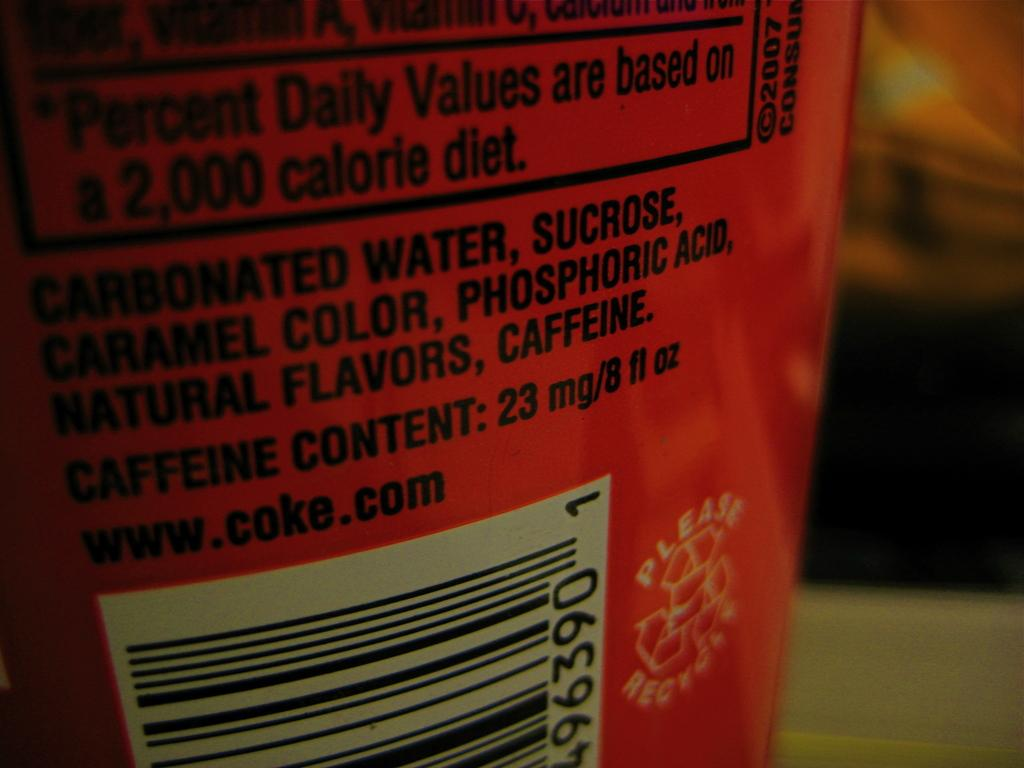<image>
Relay a brief, clear account of the picture shown. an item with the word caffeine on the back 